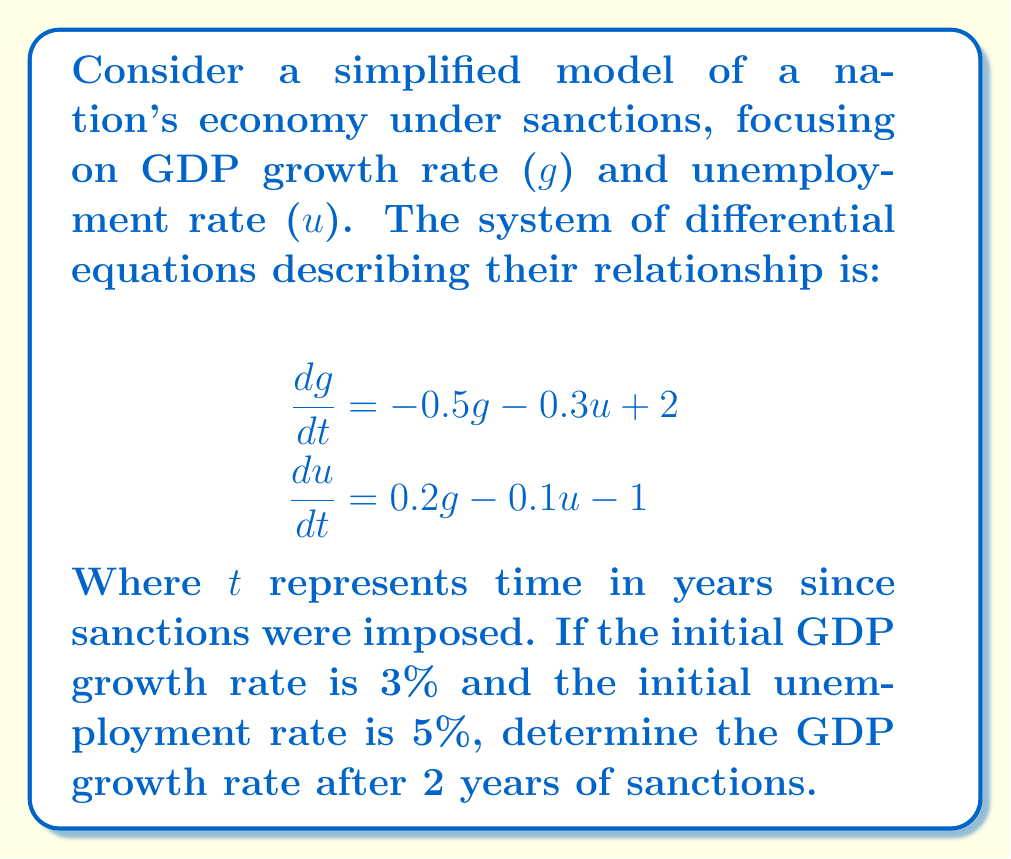Provide a solution to this math problem. To solve this problem, we need to use numerical methods to approximate the solution of the system of differential equations. We'll use the Runge-Kutta 4th order method (RK4) for better accuracy.

Step 1: Define the system of equations
Let $f_1(g,u) = -0.5g - 0.3u + 2$ and $f_2(g,u) = 0.2g - 0.1u - 1$

Step 2: Set initial conditions and time step
$g_0 = 3$, $u_0 = 5$, $\Delta t = 0.1$ (we'll use 20 steps to reach 2 years)

Step 3: Implement RK4 method
For each step:
$$\begin{align}
k_1 &= f(y_n) \\
k_2 &= f(y_n + \frac{\Delta t}{2}k_1) \\
k_3 &= f(y_n + \frac{\Delta t}{2}k_2) \\
k_4 &= f(y_n + \Delta t k_3) \\
y_{n+1} &= y_n + \frac{\Delta t}{6}(k_1 + 2k_2 + 2k_3 + k_4)
\end{align}$$

Where $y = [g, u]^T$ and $f = [f_1, f_2]^T$

Step 4: Iterate for 20 steps
After implementing the RK4 method and iterating for 20 steps, we get:

$g_{20} \approx 1.0392$

Therefore, the GDP growth rate after 2 years of sanctions is approximately 1.04%.
Answer: 1.04% 